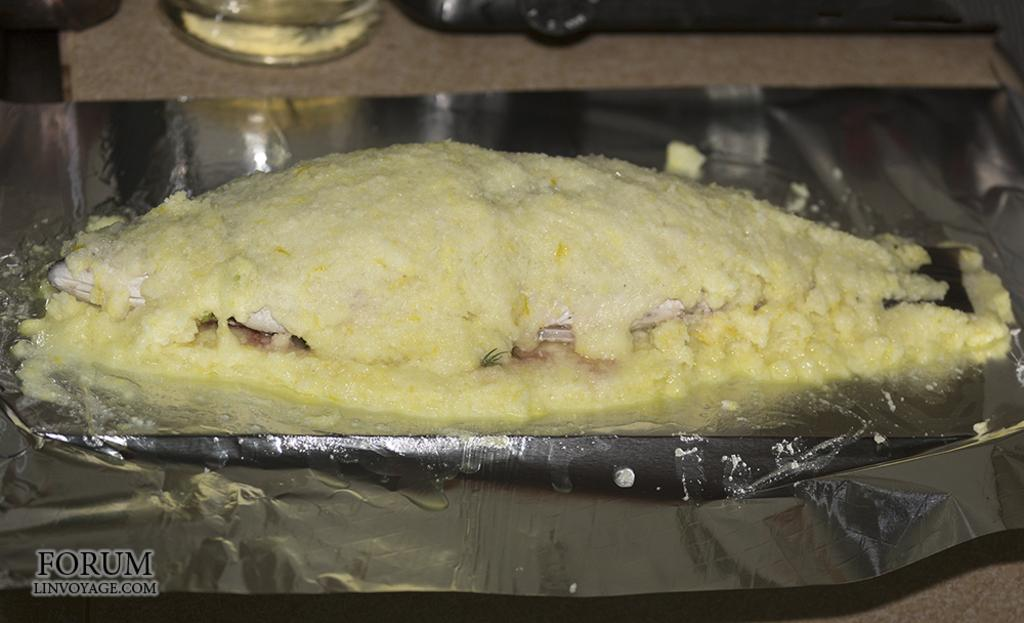What material is visible in the image? There is aluminium foil in the image. What is placed on the aluminium foil? A fish is present on the aluminium foil. How is the fish covered in the image? The fish is covered with a yellow-colored thing. Can you describe any additional features of the image? There is a watermark at the bottom of the image. What type of weather can be seen in the image? There is no indication of weather in the image, as it features a fish covered with a yellow-colored thing on aluminium foil. How many dogs are visible in the image? There are no dogs present in the image. 